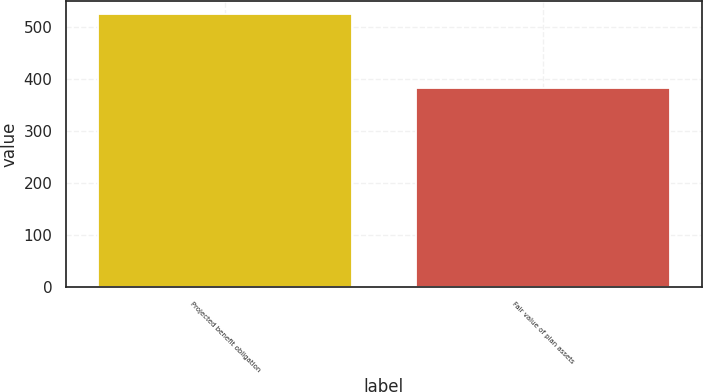<chart> <loc_0><loc_0><loc_500><loc_500><bar_chart><fcel>Projected benefit obligation<fcel>Fair value of plan assets<nl><fcel>524<fcel>383<nl></chart> 